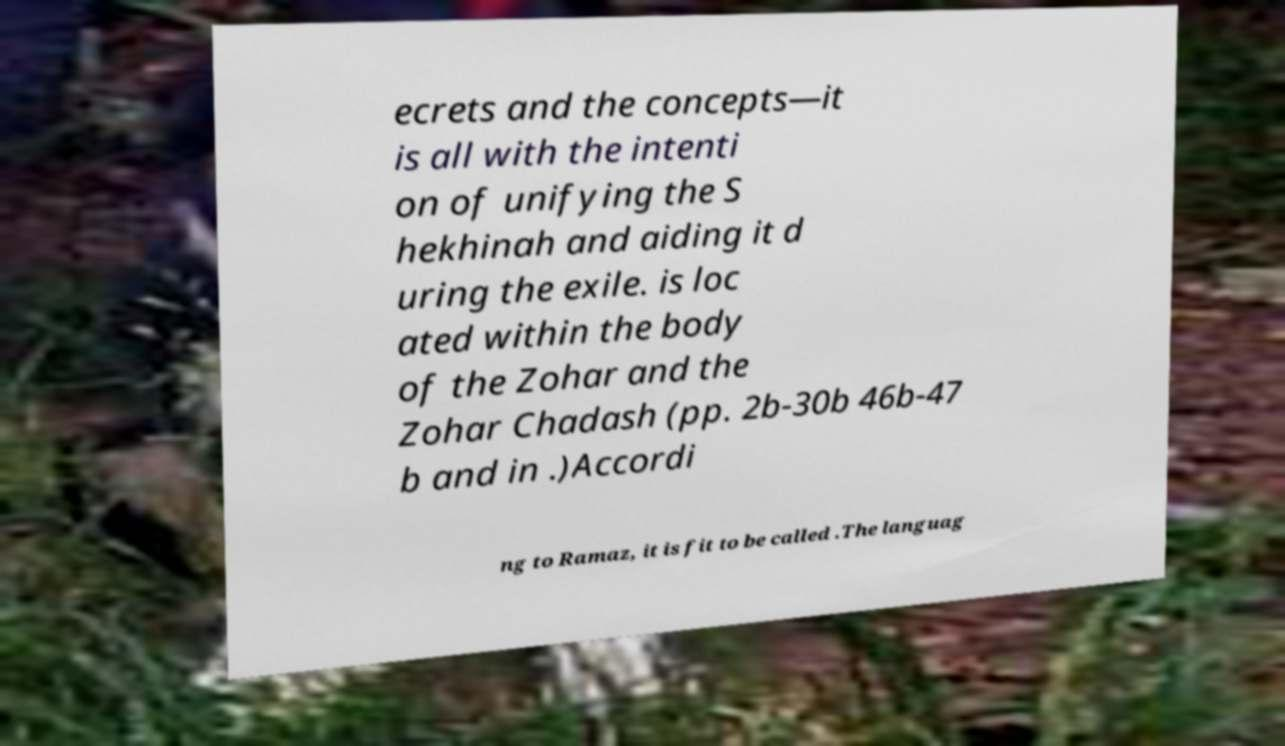Could you assist in decoding the text presented in this image and type it out clearly? ecrets and the concepts—it is all with the intenti on of unifying the S hekhinah and aiding it d uring the exile. is loc ated within the body of the Zohar and the Zohar Chadash (pp. 2b-30b 46b-47 b and in .)Accordi ng to Ramaz, it is fit to be called .The languag 